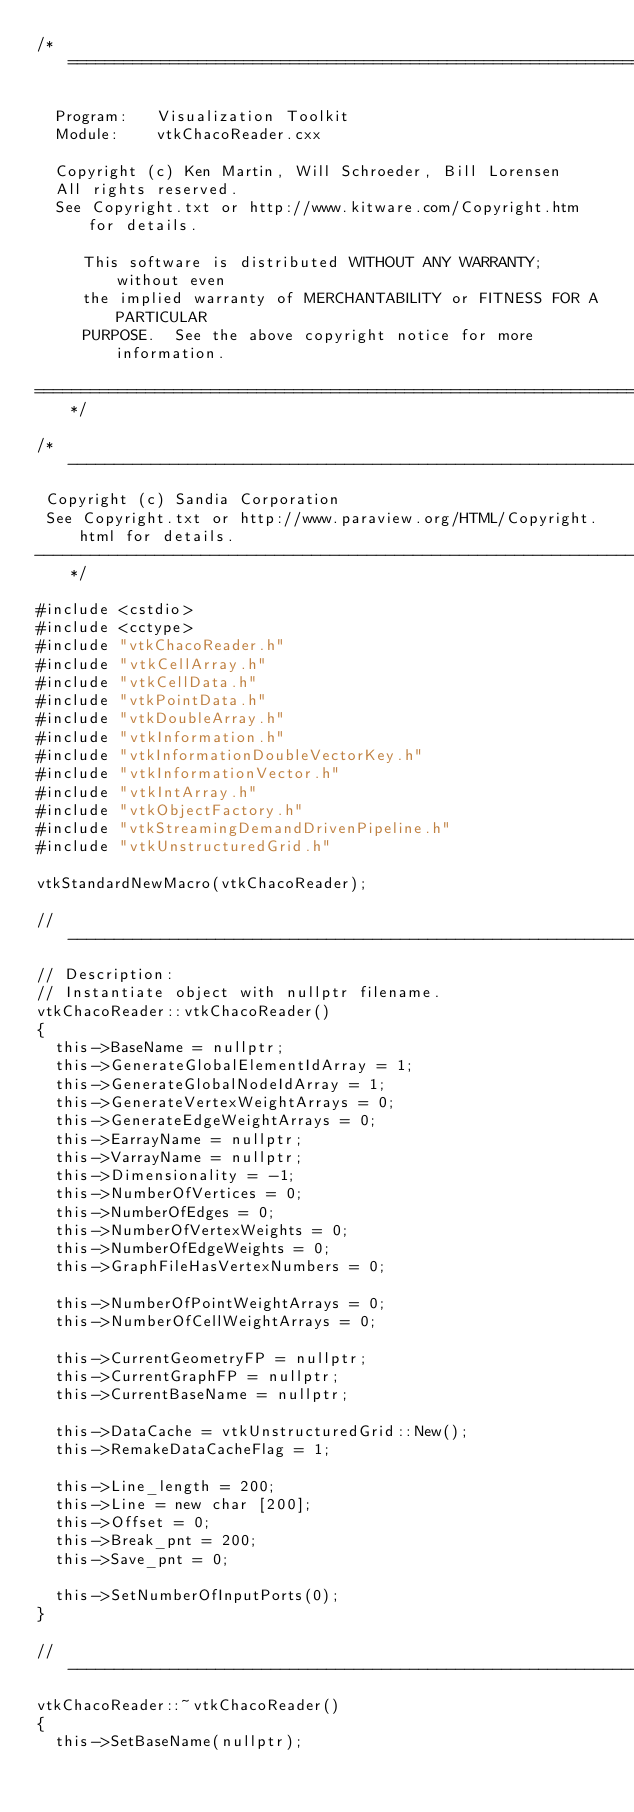<code> <loc_0><loc_0><loc_500><loc_500><_C++_>/*=========================================================================

  Program:   Visualization Toolkit
  Module:    vtkChacoReader.cxx

  Copyright (c) Ken Martin, Will Schroeder, Bill Lorensen
  All rights reserved.
  See Copyright.txt or http://www.kitware.com/Copyright.htm for details.

     This software is distributed WITHOUT ANY WARRANTY; without even
     the implied warranty of MERCHANTABILITY or FITNESS FOR A PARTICULAR
     PURPOSE.  See the above copyright notice for more information.

=========================================================================*/

/*----------------------------------------------------------------------------
 Copyright (c) Sandia Corporation
 See Copyright.txt or http://www.paraview.org/HTML/Copyright.html for details.
----------------------------------------------------------------------------*/

#include <cstdio>
#include <cctype>
#include "vtkChacoReader.h"
#include "vtkCellArray.h"
#include "vtkCellData.h"
#include "vtkPointData.h"
#include "vtkDoubleArray.h"
#include "vtkInformation.h"
#include "vtkInformationDoubleVectorKey.h"
#include "vtkInformationVector.h"
#include "vtkIntArray.h"
#include "vtkObjectFactory.h"
#include "vtkStreamingDemandDrivenPipeline.h"
#include "vtkUnstructuredGrid.h"

vtkStandardNewMacro(vtkChacoReader);

//----------------------------------------------------------------------------
// Description:
// Instantiate object with nullptr filename.
vtkChacoReader::vtkChacoReader()
{
  this->BaseName = nullptr;
  this->GenerateGlobalElementIdArray = 1;
  this->GenerateGlobalNodeIdArray = 1;
  this->GenerateVertexWeightArrays = 0;
  this->GenerateEdgeWeightArrays = 0;
  this->EarrayName = nullptr;
  this->VarrayName = nullptr;
  this->Dimensionality = -1;
  this->NumberOfVertices = 0;
  this->NumberOfEdges = 0;
  this->NumberOfVertexWeights = 0;
  this->NumberOfEdgeWeights = 0;
  this->GraphFileHasVertexNumbers = 0;

  this->NumberOfPointWeightArrays = 0;
  this->NumberOfCellWeightArrays = 0;

  this->CurrentGeometryFP = nullptr;
  this->CurrentGraphFP = nullptr;
  this->CurrentBaseName = nullptr;

  this->DataCache = vtkUnstructuredGrid::New();
  this->RemakeDataCacheFlag = 1;

  this->Line_length = 200;
  this->Line = new char [200];
  this->Offset = 0;
  this->Break_pnt = 200;
  this->Save_pnt = 0;

  this->SetNumberOfInputPorts(0);
}

//----------------------------------------------------------------------------
vtkChacoReader::~vtkChacoReader()
{
  this->SetBaseName(nullptr);</code> 